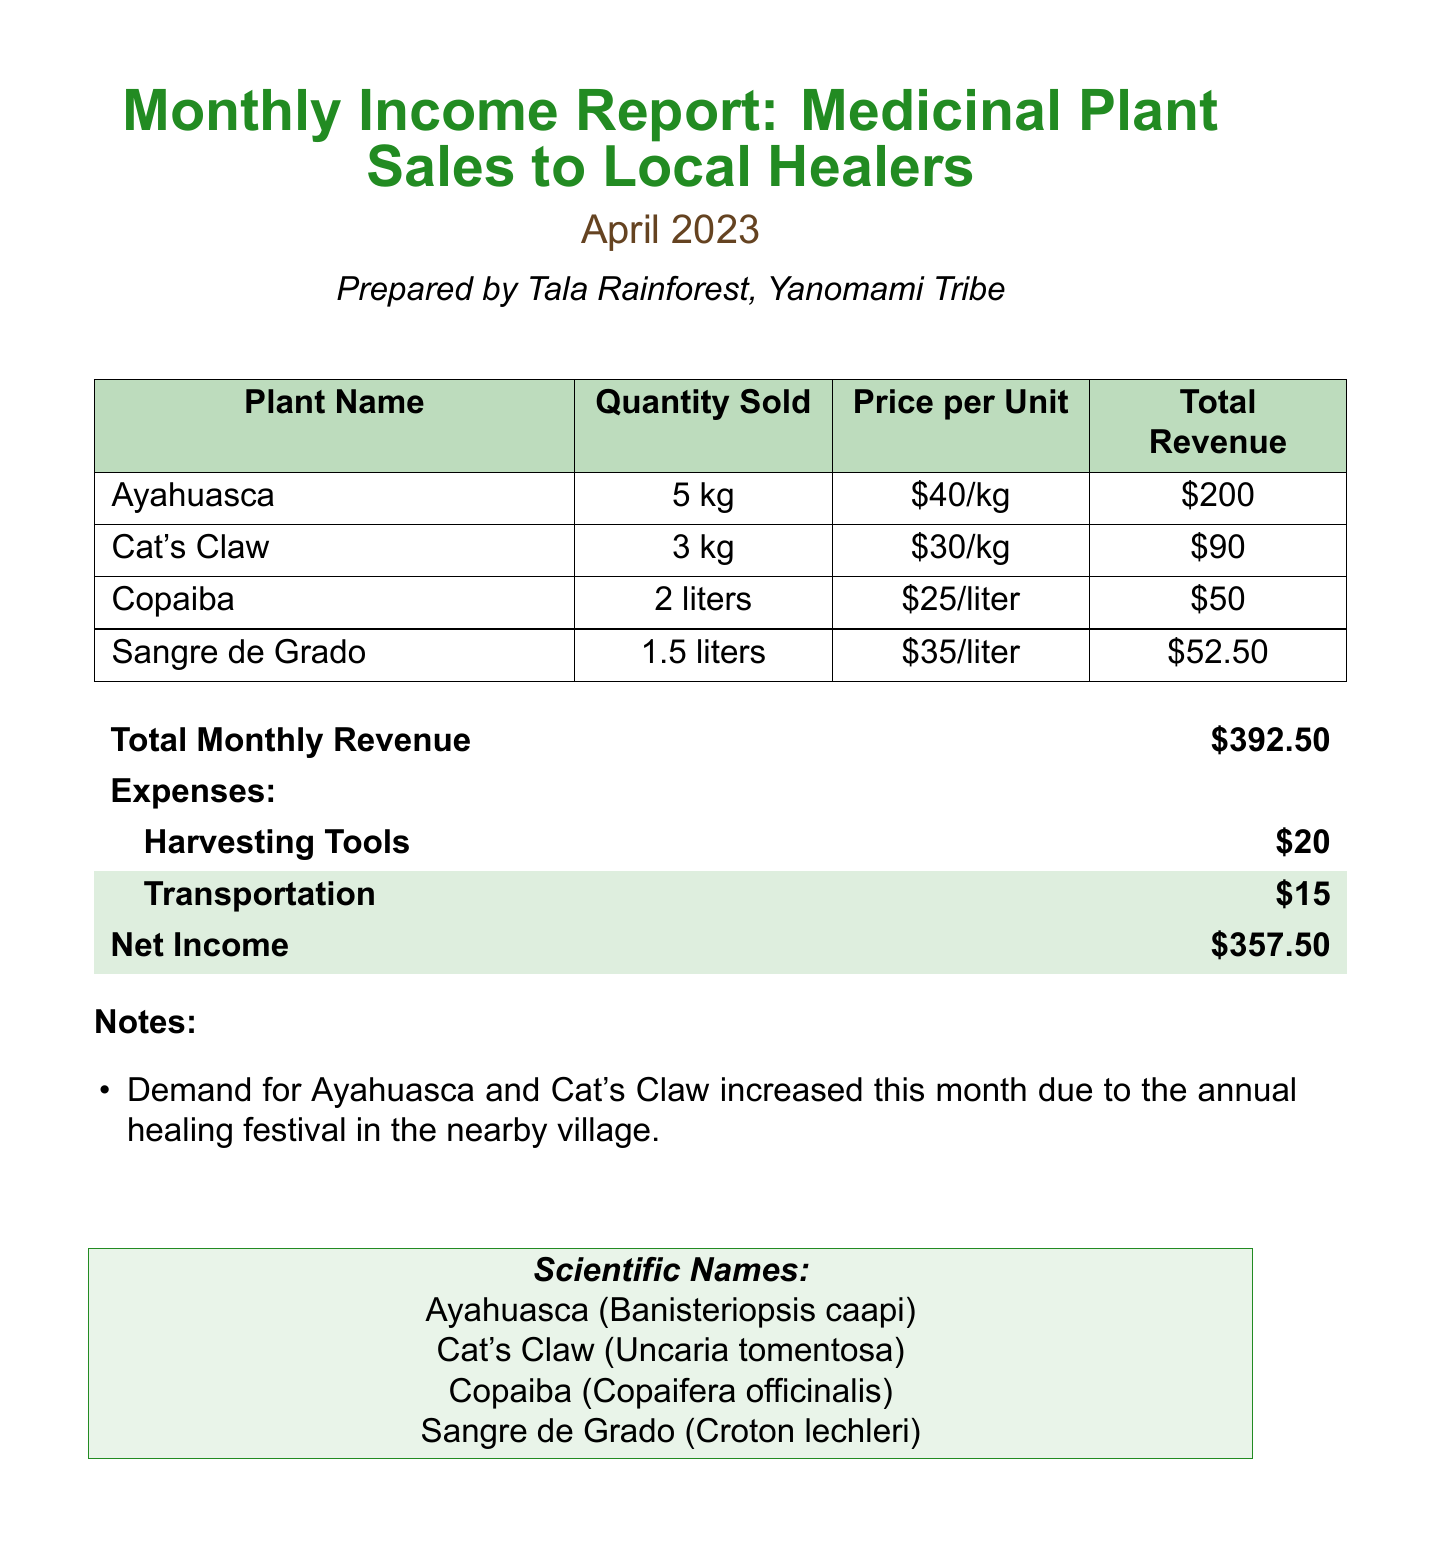What is the report title? The report title can be found at the beginning of the document.
Answer: Monthly Income Report: Medicinal Plant Sales to Local Healers Who prepared the report? The seller's name is indicated in the document, which is the preparer of the report.
Answer: Tala Rainforest What is the total monthly revenue? The total monthly revenue is stated clearly in the financial section of the document.
Answer: $392.50 How much Ayahuasca was sold? The quantity sold for Ayahuasca is detailed in the sales data section.
Answer: 5 kg What was the price per liter of Copaiba? The price per liter is provided next to the quantity sold for Copaiba.
Answer: $25 What was the expense for transportation? The expense for transportation is listed under the expenses section of the document.
Answer: $15 What is the net income for the month? The net income is calculated and presented in the financial summary.
Answer: $357.50 Why did the demand for Ayahuasca increase? The notes section explains the reason for the increased demand.
Answer: Annual healing festival What is the scientific name of Cat's Claw? The scientific name for Cat's Claw is specified at the end of the document.
Answer: Uncaria tomentosa 